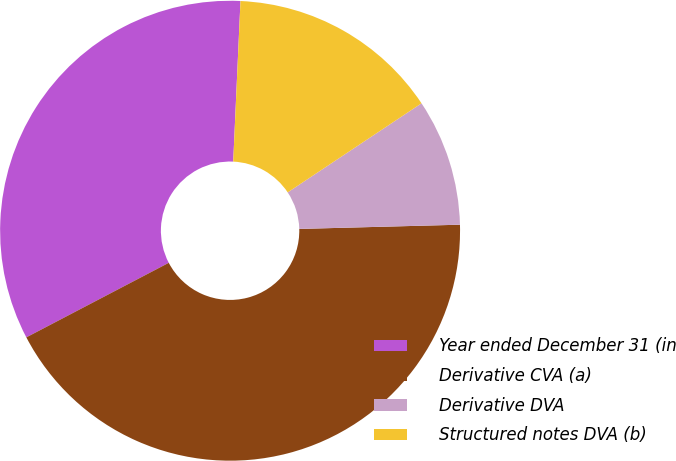<chart> <loc_0><loc_0><loc_500><loc_500><pie_chart><fcel>Year ended December 31 (in<fcel>Derivative CVA (a)<fcel>Derivative DVA<fcel>Structured notes DVA (b)<nl><fcel>33.39%<fcel>42.74%<fcel>8.93%<fcel>14.93%<nl></chart> 